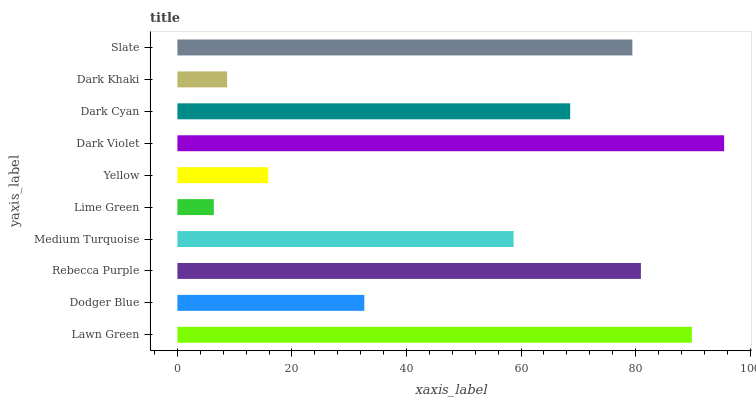Is Lime Green the minimum?
Answer yes or no. Yes. Is Dark Violet the maximum?
Answer yes or no. Yes. Is Dodger Blue the minimum?
Answer yes or no. No. Is Dodger Blue the maximum?
Answer yes or no. No. Is Lawn Green greater than Dodger Blue?
Answer yes or no. Yes. Is Dodger Blue less than Lawn Green?
Answer yes or no. Yes. Is Dodger Blue greater than Lawn Green?
Answer yes or no. No. Is Lawn Green less than Dodger Blue?
Answer yes or no. No. Is Dark Cyan the high median?
Answer yes or no. Yes. Is Medium Turquoise the low median?
Answer yes or no. Yes. Is Dark Khaki the high median?
Answer yes or no. No. Is Dark Khaki the low median?
Answer yes or no. No. 